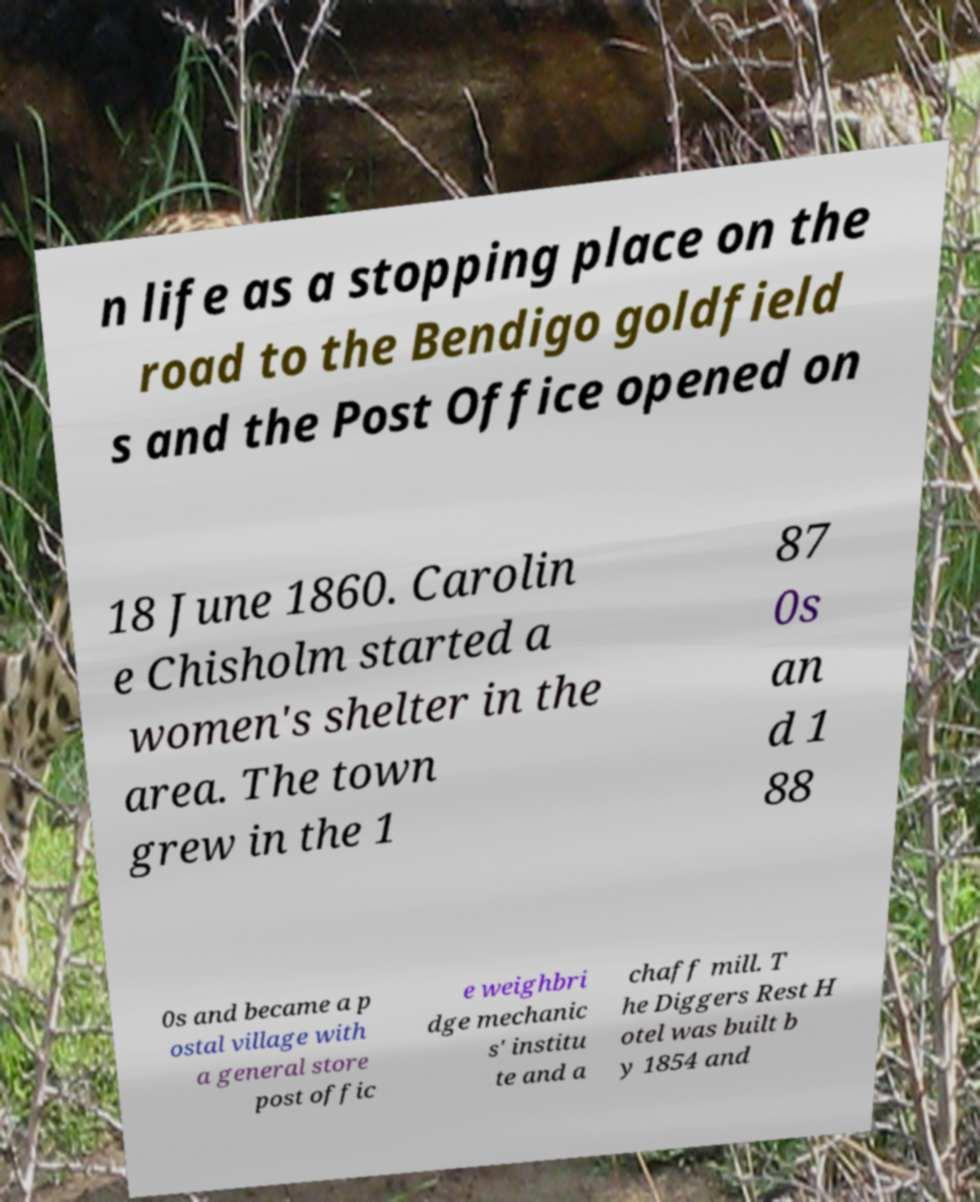There's text embedded in this image that I need extracted. Can you transcribe it verbatim? n life as a stopping place on the road to the Bendigo goldfield s and the Post Office opened on 18 June 1860. Carolin e Chisholm started a women's shelter in the area. The town grew in the 1 87 0s an d 1 88 0s and became a p ostal village with a general store post offic e weighbri dge mechanic s' institu te and a chaff mill. T he Diggers Rest H otel was built b y 1854 and 